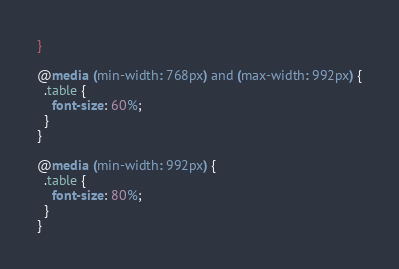<code> <loc_0><loc_0><loc_500><loc_500><_CSS_>}

@media (min-width: 768px) and (max-width: 992px) {
  .table {
    font-size: 60%;
  }
}

@media (min-width: 992px) {
  .table {
    font-size: 80%;
  }
}

</code> 